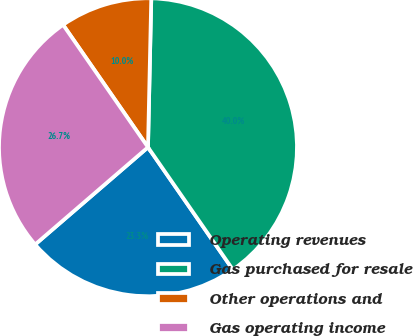Convert chart to OTSL. <chart><loc_0><loc_0><loc_500><loc_500><pie_chart><fcel>Operating revenues<fcel>Gas purchased for resale<fcel>Other operations and<fcel>Gas operating income<nl><fcel>23.33%<fcel>40.0%<fcel>10.0%<fcel>26.67%<nl></chart> 